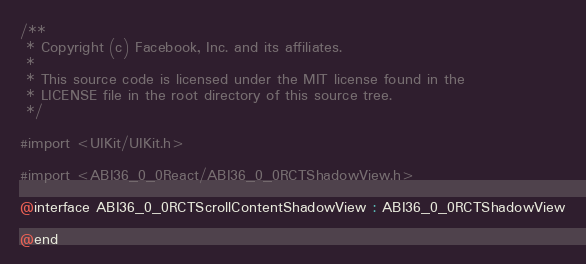<code> <loc_0><loc_0><loc_500><loc_500><_C_>/**
 * Copyright (c) Facebook, Inc. and its affiliates.
 *
 * This source code is licensed under the MIT license found in the
 * LICENSE file in the root directory of this source tree.
 */

#import <UIKit/UIKit.h>

#import <ABI36_0_0React/ABI36_0_0RCTShadowView.h>

@interface ABI36_0_0RCTScrollContentShadowView : ABI36_0_0RCTShadowView

@end
</code> 